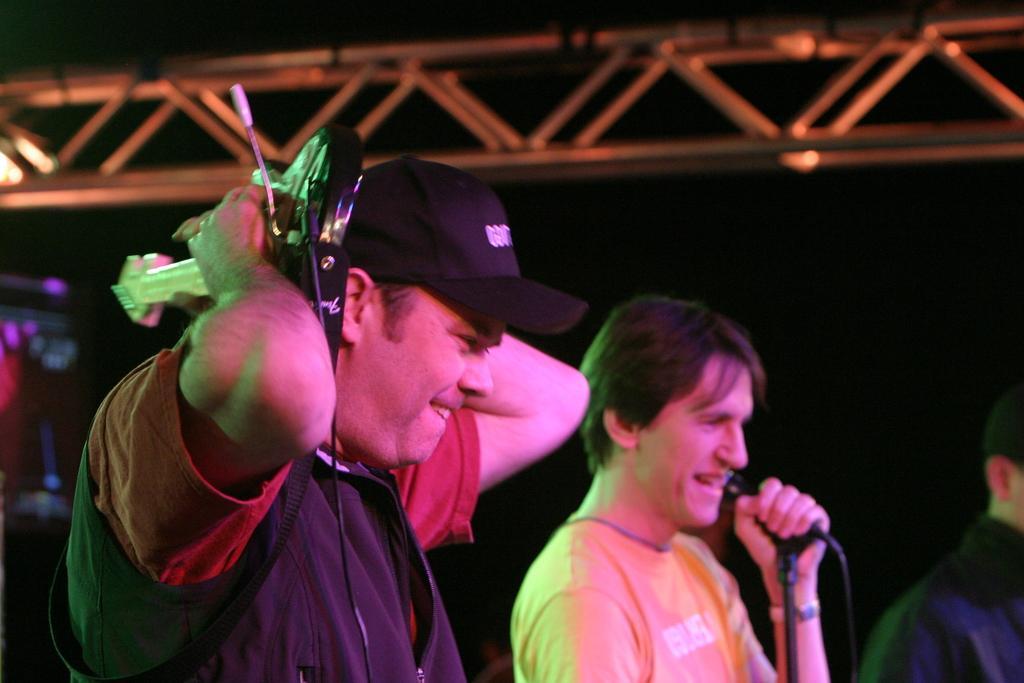In one or two sentences, can you explain what this image depicts? At the right side of the picture we can see one man standing and singing by holding a mike in his hand. Here we can see one man wearing a black cap holding a musical instrument in his hand. 